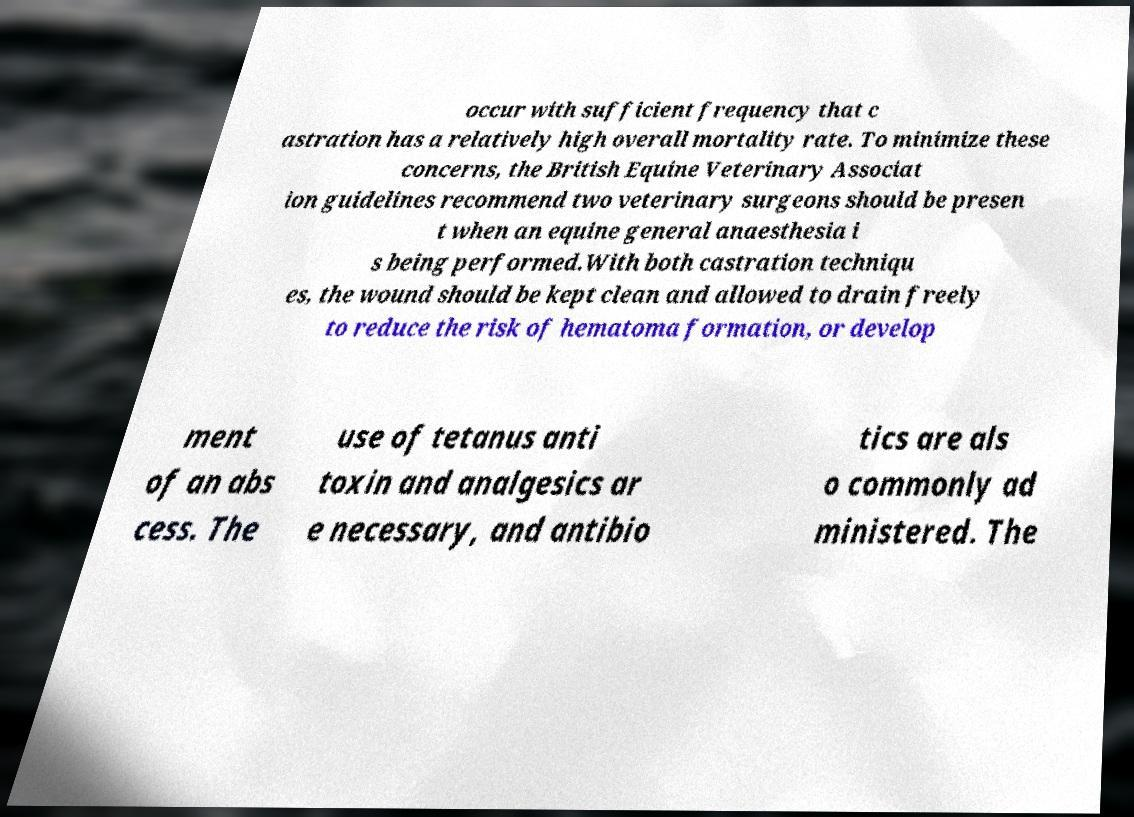Can you read and provide the text displayed in the image?This photo seems to have some interesting text. Can you extract and type it out for me? occur with sufficient frequency that c astration has a relatively high overall mortality rate. To minimize these concerns, the British Equine Veterinary Associat ion guidelines recommend two veterinary surgeons should be presen t when an equine general anaesthesia i s being performed.With both castration techniqu es, the wound should be kept clean and allowed to drain freely to reduce the risk of hematoma formation, or develop ment of an abs cess. The use of tetanus anti toxin and analgesics ar e necessary, and antibio tics are als o commonly ad ministered. The 